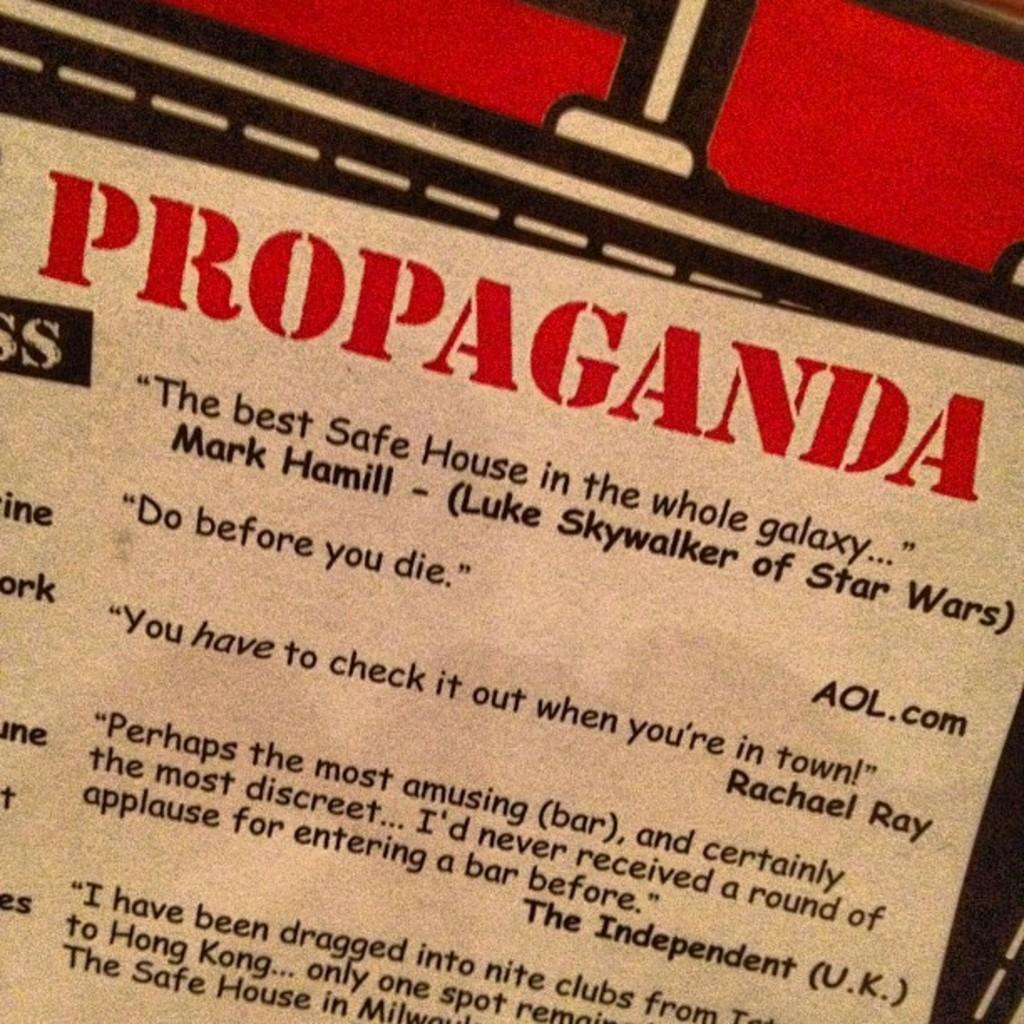<image>
Present a compact description of the photo's key features. A piece of text with large red words that say Propaganda. 